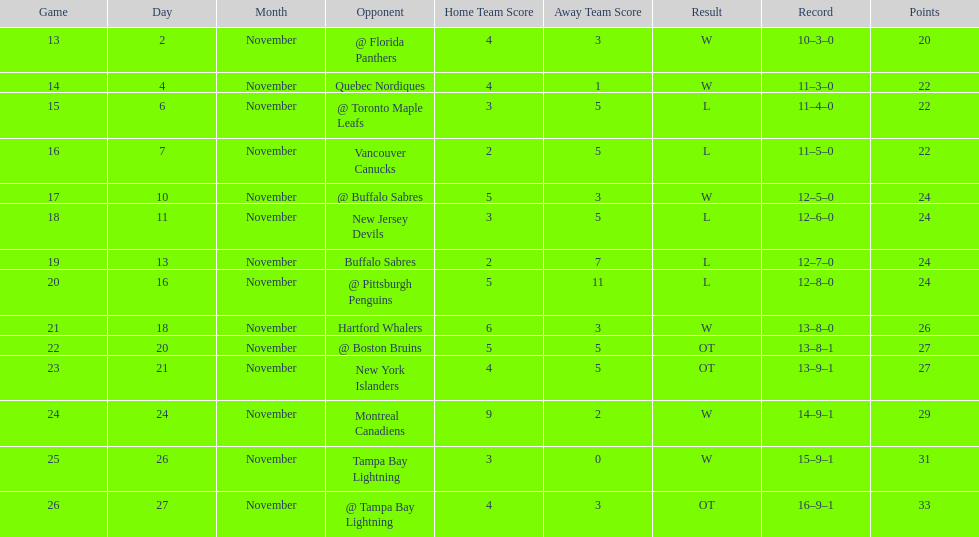Did the tampa bay lightning have the least amount of wins? Yes. 